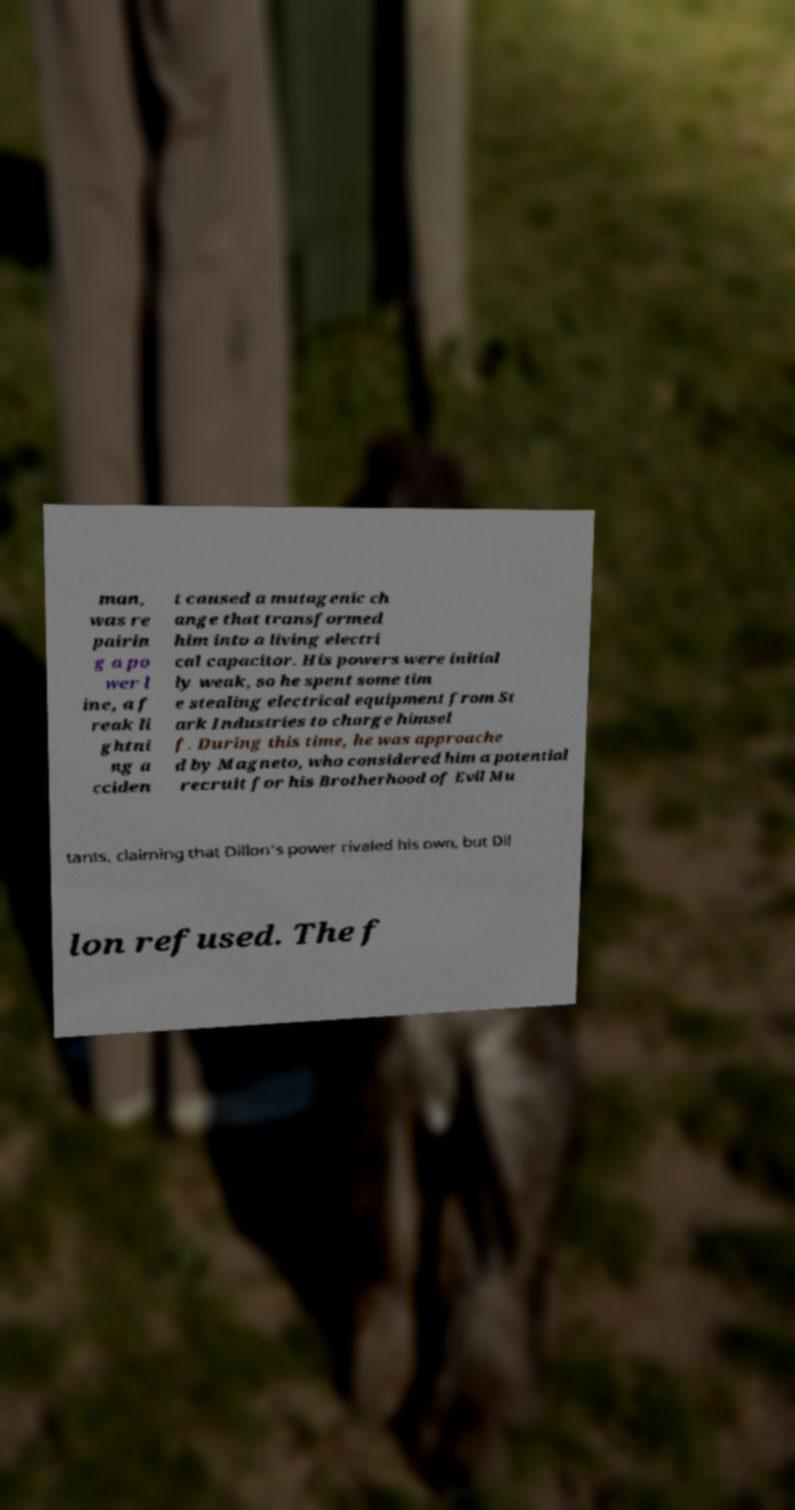I need the written content from this picture converted into text. Can you do that? man, was re pairin g a po wer l ine, a f reak li ghtni ng a cciden t caused a mutagenic ch ange that transformed him into a living electri cal capacitor. His powers were initial ly weak, so he spent some tim e stealing electrical equipment from St ark Industries to charge himsel f. During this time, he was approache d by Magneto, who considered him a potential recruit for his Brotherhood of Evil Mu tants, claiming that Dillon's power rivaled his own, but Dil lon refused. The f 